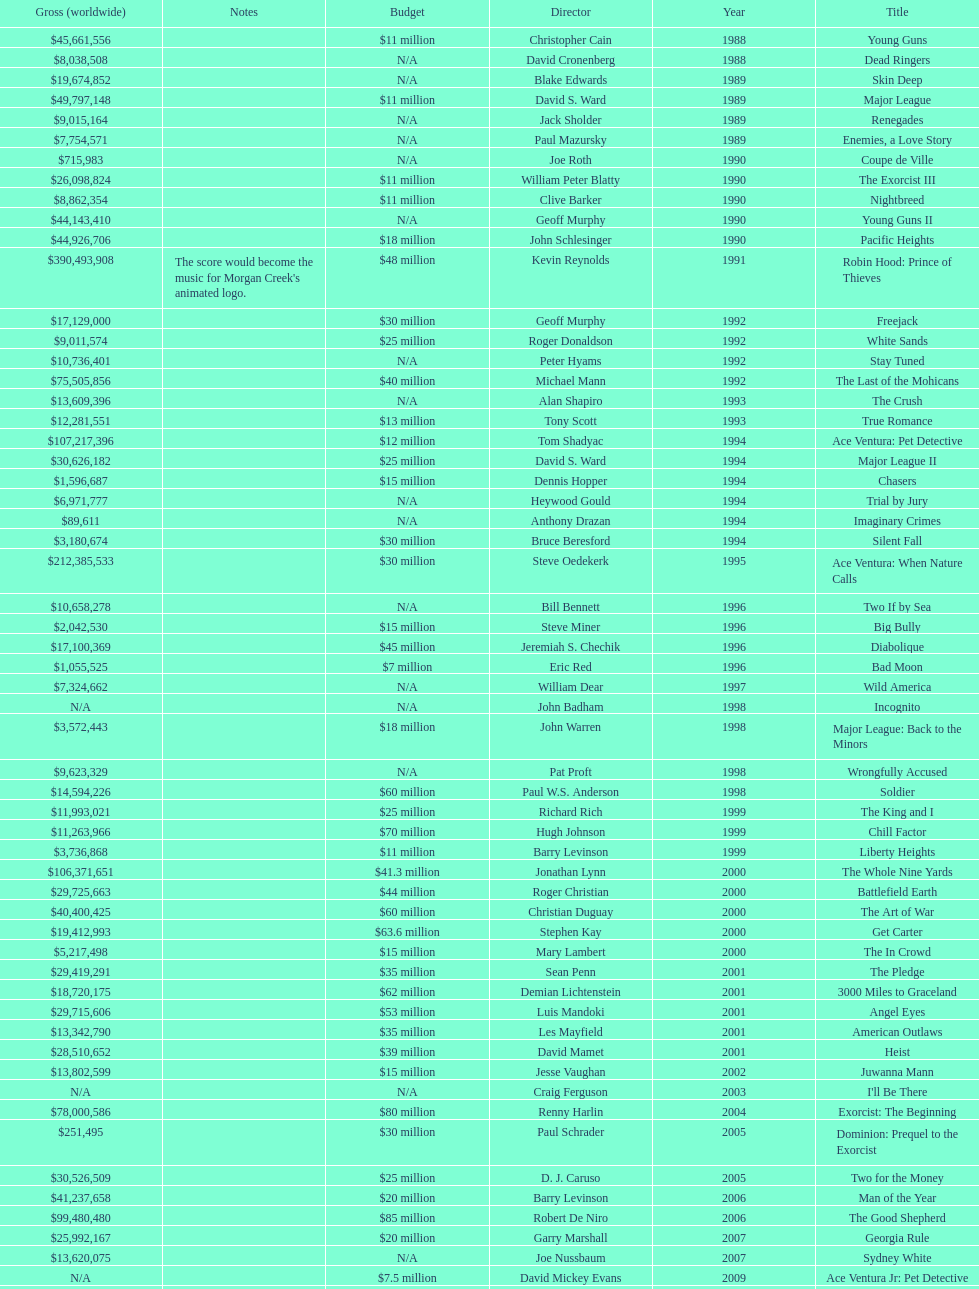How many films did morgan creek make in 2006? 2. 